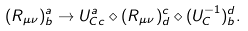<formula> <loc_0><loc_0><loc_500><loc_500>( R _ { \mu \nu } ) ^ { a } _ { b } \rightarrow U ^ { a } _ { C c } \diamond ( R _ { \mu \nu } ) ^ { c } _ { d } \diamond ( U _ { C } ^ { - 1 } ) ^ { d } _ { b } .</formula> 